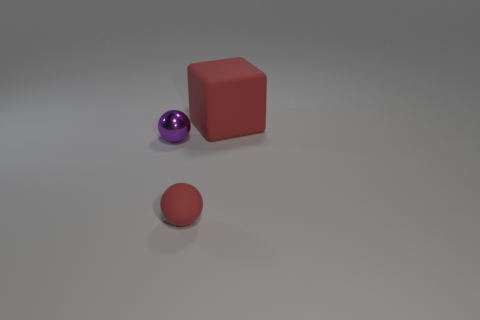Subtract all balls. How many objects are left? 1 Subtract 1 blocks. How many blocks are left? 0 Subtract all red spheres. How many spheres are left? 1 Subtract all cyan blocks. How many purple spheres are left? 1 Subtract all cyan shiny objects. Subtract all rubber things. How many objects are left? 1 Add 2 tiny shiny things. How many tiny shiny things are left? 3 Add 3 tiny rubber balls. How many tiny rubber balls exist? 4 Add 2 tiny red rubber things. How many objects exist? 5 Subtract 1 purple spheres. How many objects are left? 2 Subtract all green spheres. Subtract all red cubes. How many spheres are left? 2 